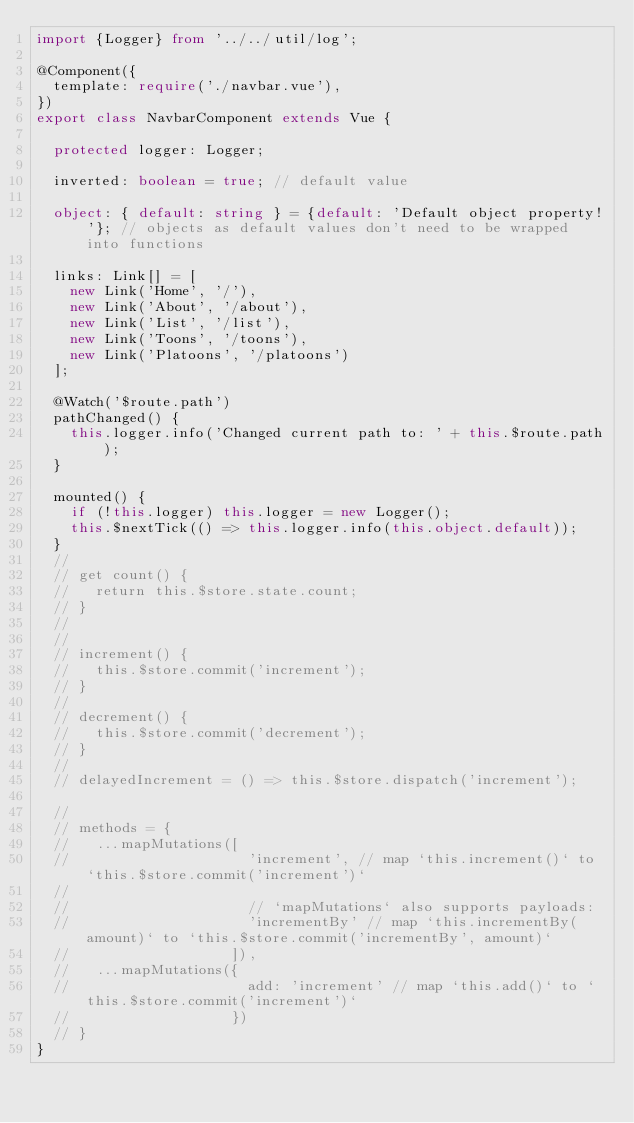Convert code to text. <code><loc_0><loc_0><loc_500><loc_500><_TypeScript_>import {Logger} from '../../util/log';

@Component({
  template: require('./navbar.vue'),
})
export class NavbarComponent extends Vue {

  protected logger: Logger;

  inverted: boolean = true; // default value

  object: { default: string } = {default: 'Default object property!'}; // objects as default values don't need to be wrapped into functions

  links: Link[] = [
    new Link('Home', '/'),
    new Link('About', '/about'),
    new Link('List', '/list'),
    new Link('Toons', '/toons'),
    new Link('Platoons', '/platoons')
  ];

  @Watch('$route.path')
  pathChanged() {
    this.logger.info('Changed current path to: ' + this.$route.path);
  }

  mounted() {
    if (!this.logger) this.logger = new Logger();
    this.$nextTick(() => this.logger.info(this.object.default));
  }
  //
  // get count() {
  //   return this.$store.state.count;
  // }
  //
  //
  // increment() {
  //   this.$store.commit('increment');
  // }
  //
  // decrement() {
  //   this.$store.commit('decrement');
  // }
  //
  // delayedIncrement = () => this.$store.dispatch('increment');

  //
  // methods = {
  //   ...mapMutations([
  //                     'increment', // map `this.increment()` to `this.$store.commit('increment')`
  //
  //                     // `mapMutations` also supports payloads:
  //                     'incrementBy' // map `this.incrementBy(amount)` to `this.$store.commit('incrementBy', amount)`
  //                   ]),
  //   ...mapMutations({
  //                     add: 'increment' // map `this.add()` to `this.$store.commit('increment')`
  //                   })
  // }
}
</code> 